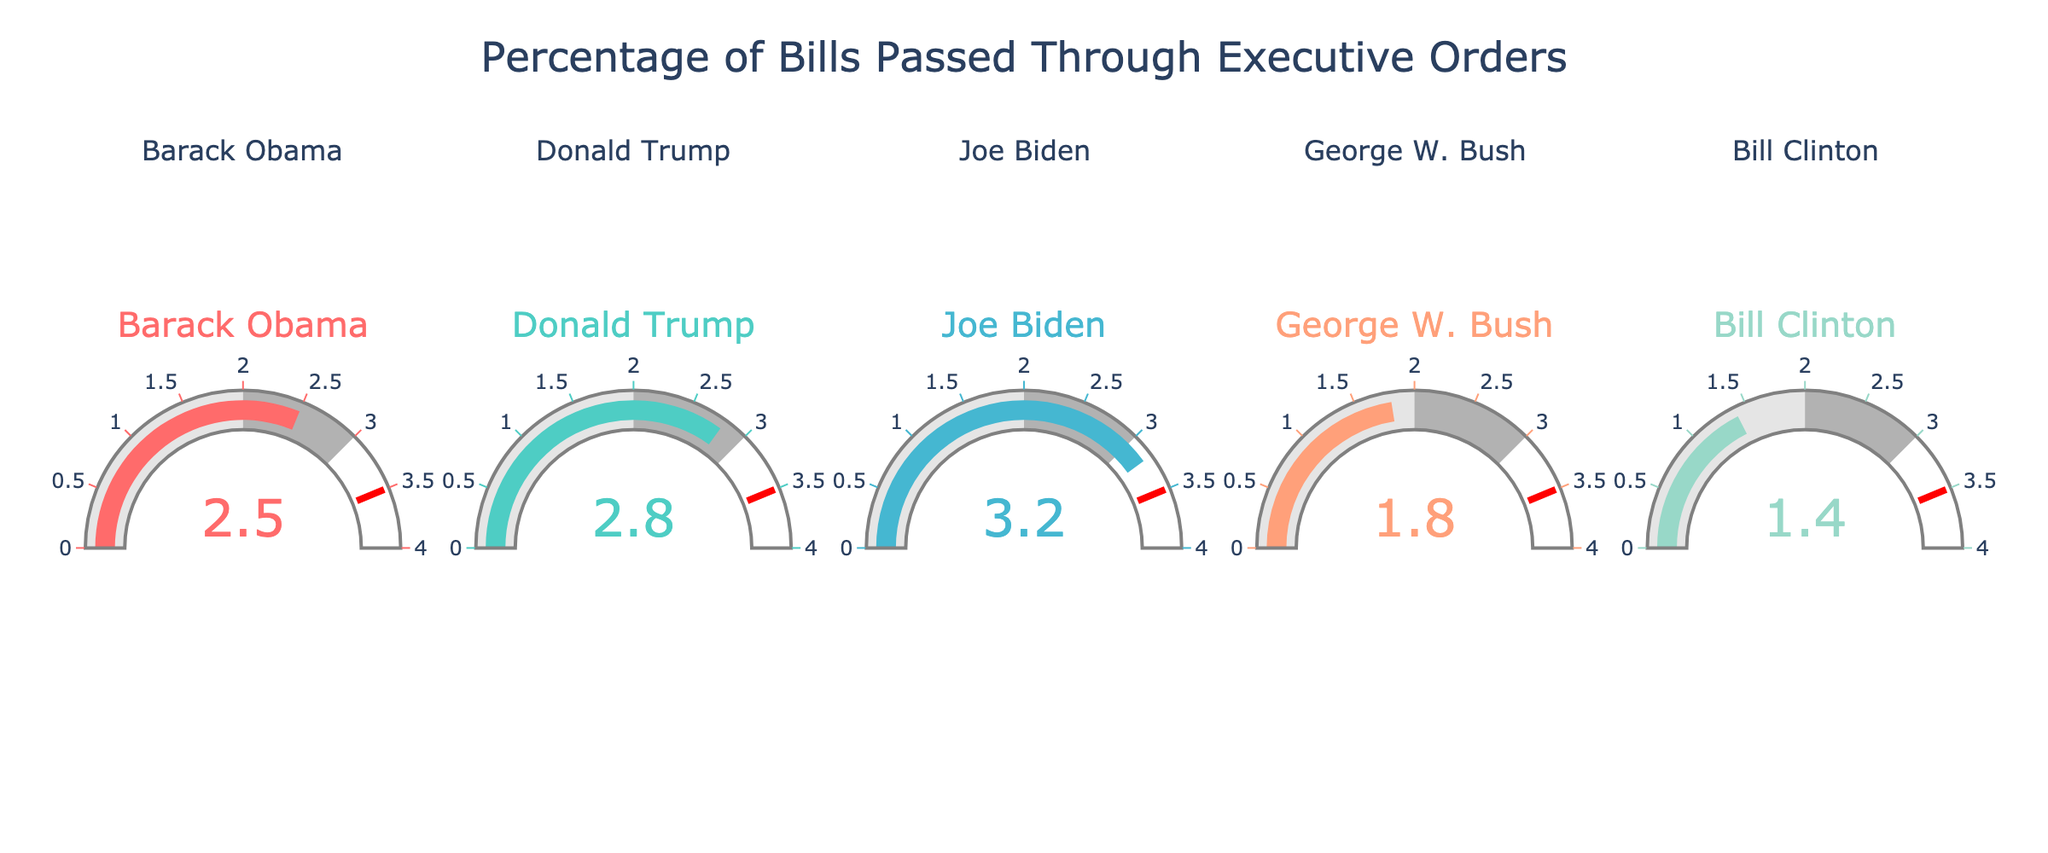What is the title of the figure? The title is usually displayed at the top of the figure. It provides context about the visualized data. In this case, the title is visible at the top.
Answer: Percentage of Bills Passed Through Executive Orders Which President has the highest percentage of bills passed through executive orders? By looking at the gauge with the highest value, we can determine which President has the highest percentage. Joe Biden's gauge shows 3.2%, which is the highest.
Answer: Joe Biden What is the color of the gauge for Donald Trump? Each gauge is associated with a unique color. Observing the gauge for Donald Trump, it shows a greenish shade.
Answer: Greenish (#4ECDC4) What is the range displayed on the gauges? The range of the percentage values is indicated on the gauge axis, which typically runs from the minimum to maximum values. All the gauges display a range from 0 to 4.
Answer: 0 to 4 Who's the President with the lowest percentage? To find the lowest, we need to identify the gauge with the smallest value. Bill Clinton's gauge shows 1.4%, which is the lowest among the displayed values.
Answer: Bill Clinton Calculate the average percentage of bills passed through executive orders for the Presidents shown? To find the average, sum all the percentages and divide by the number of Presidents. (2.5 + 2.8 + 3.2 + 1.8 + 1.4) / 5 = 11.7 / 5 = 2.34
Answer: 2.34 Which Presidents have a percentage between 2.0 and 3.0? We need to identify the values within the specified range by examining each corresponding gauge. Barack Obama (2.5) and Donald Trump (2.8) fall within this range.
Answer: Barack Obama, Donald Trump What is the difference in the percentage of bills passed through executive orders between George W. Bush and Joe Biden? Subtract the percentage of George W. Bush from Joe Biden's. 3.2 (Biden) - 1.8 (Bush) = 1.4
Answer: 1.4 How many Presidents have a percentage of bills passed through executive orders above the 2.0 threshold? Count the number of gauges where the value is greater than 2.0. Barack Obama (2.5), Donald Trump (2.8), and Joe Biden (3.2) exceed this threshold.
Answer: 3 Which President has a percentage closest to the average percentage of bills passed through executive orders? First find the average (2.34). Then identify the percentage closest to it. Barack Obama's 2.5 is the nearest to 2.34.
Answer: Barack Obama 